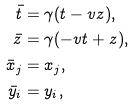Convert formula to latex. <formula><loc_0><loc_0><loc_500><loc_500>\bar { t } & = \gamma ( t - v z ) , \\ \bar { z } & = \gamma ( - v t + z ) , \\ \bar { x } _ { j } & = x _ { j } , \\ \bar { y } _ { i } & = y _ { i } ,</formula> 